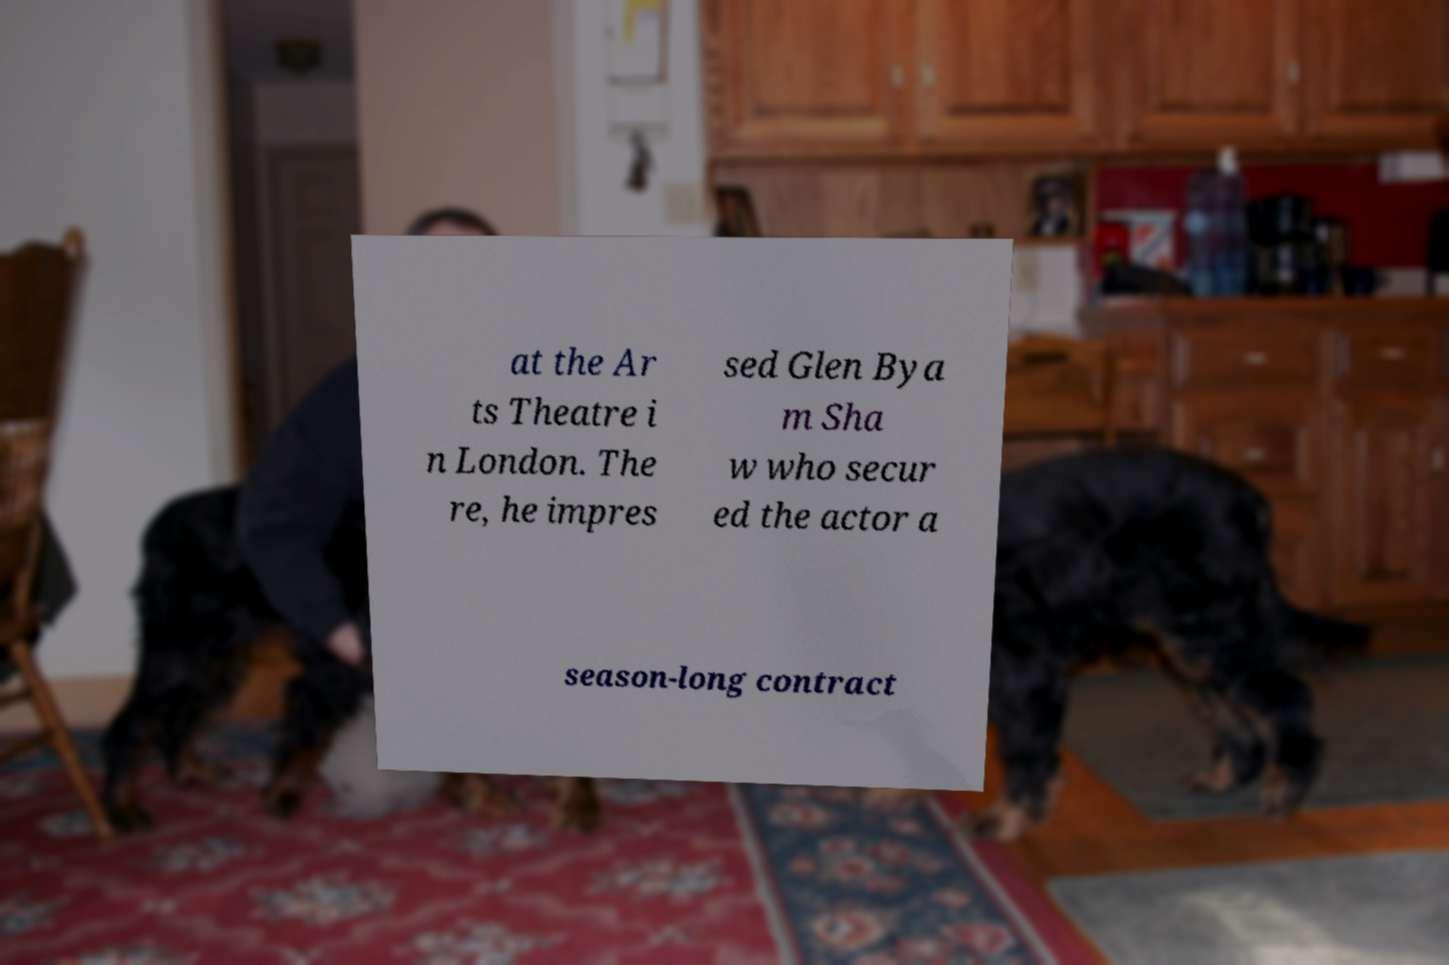Could you extract and type out the text from this image? at the Ar ts Theatre i n London. The re, he impres sed Glen Bya m Sha w who secur ed the actor a season-long contract 